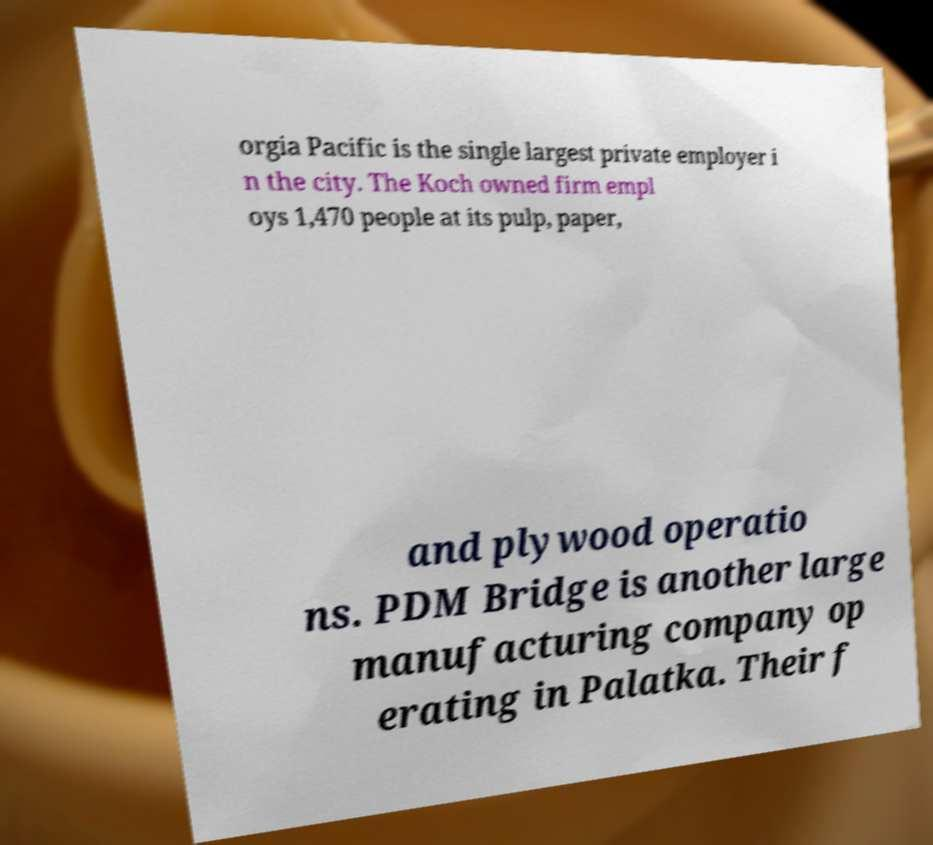I need the written content from this picture converted into text. Can you do that? orgia Pacific is the single largest private employer i n the city. The Koch owned firm empl oys 1,470 people at its pulp, paper, and plywood operatio ns. PDM Bridge is another large manufacturing company op erating in Palatka. Their f 